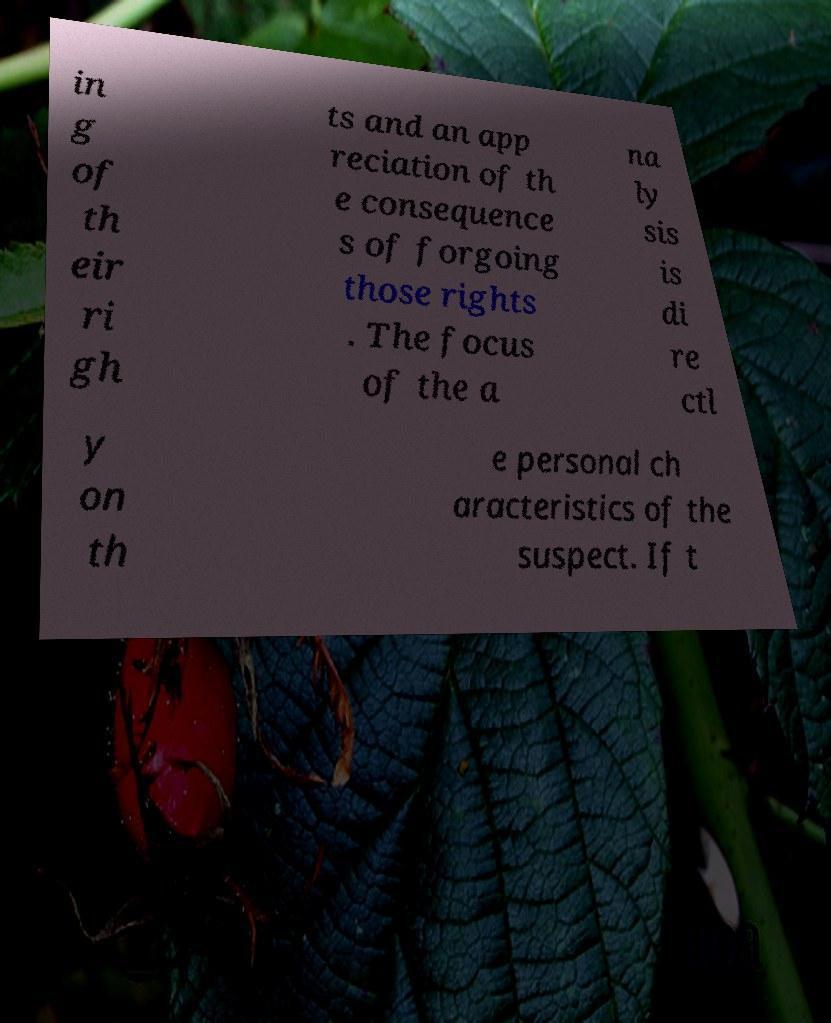Please identify and transcribe the text found in this image. in g of th eir ri gh ts and an app reciation of th e consequence s of forgoing those rights . The focus of the a na ly sis is di re ctl y on th e personal ch aracteristics of the suspect. If t 